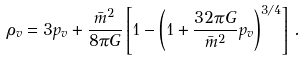Convert formula to latex. <formula><loc_0><loc_0><loc_500><loc_500>\rho _ { v } = 3 p _ { v } + \frac { { \bar { m } } ^ { 2 } } { 8 \pi G } \left [ 1 - \left ( 1 + \frac { 3 2 \pi G } { { \bar { m } } ^ { 2 } } p _ { v } \right ) ^ { 3 / 4 } \right ] \, .</formula> 